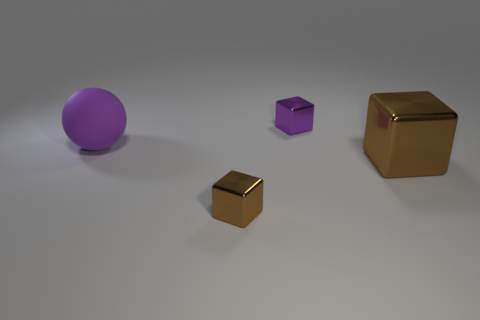Subtract all gray cylinders. How many brown blocks are left? 2 Subtract all tiny blocks. How many blocks are left? 1 Add 4 big red metallic spheres. How many objects exist? 8 Subtract all cubes. How many objects are left? 1 Subtract all tiny purple cubes. Subtract all matte objects. How many objects are left? 2 Add 3 tiny purple metal objects. How many tiny purple metal objects are left? 4 Add 1 small yellow cylinders. How many small yellow cylinders exist? 1 Subtract 0 green cubes. How many objects are left? 4 